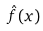Convert formula to latex. <formula><loc_0><loc_0><loc_500><loc_500>\hat { f } ( x )</formula> 